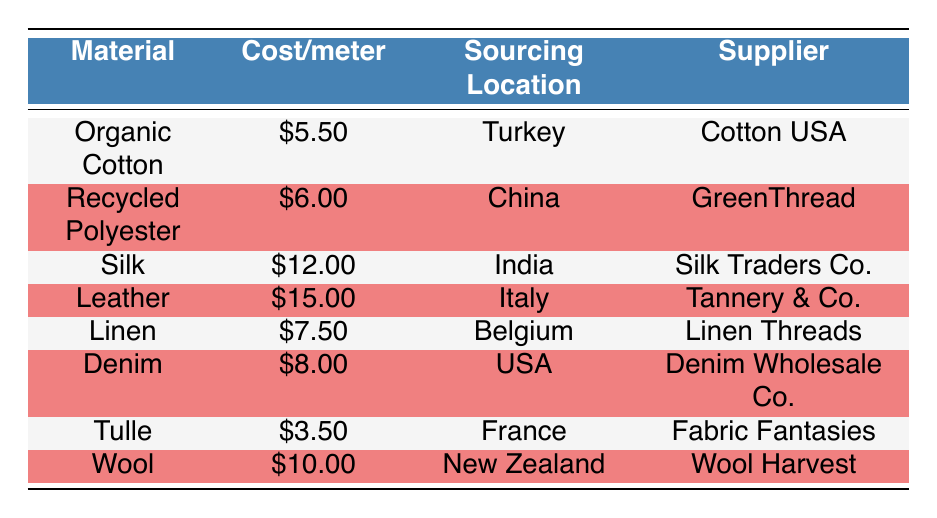What is the cost per meter of Organic Cotton? The table shows that the cost per meter of Organic Cotton is listed under the "Cost/meter" column next to the "Organic Cotton" row. This value is \$5.50.
Answer: \$5.50 Which material is sourced from Italy? Looking at the sourcing location column, we find that Leather is the material sourced from Italy.
Answer: Leather What is the average cost per meter of all materials listed? To find the average, we first sum the cost per meter of each material: \$5.50 + \$6.00 + \$12.00 + \$15.00 + \$7.50 + \$8.00 + \$3.50 + \$10.00 = \$67.50. There are 8 materials, so the average cost is \$67.50 / 8 = \$8.44.
Answer: \$8.44 Is Silk the most expensive material on the list? By comparing the cost per meter of Silk, which is \$12.00, with all other materials, we see that Leather at \$15.00 is more expensive than Silk. Therefore, Silk is not the most expensive material.
Answer: No What is the sourcing location of the material with the highest cost per meter? The material with the highest cost per meter is Leather, costing \$15.00. Referencing the sourcing location column for this row, we find it is sourced from Italy.
Answer: Italy Which two materials have a cost per meter below \$7? We look at the cost per meter column and find Tulle at \$3.50 and Organic Cotton at \$5.50. Both of these materials have costs below \$7.
Answer: Tulle and Organic Cotton Is there any material sourced from the USA? Checking the sourcing location column reveals that Denim is the only material listed with the USA as its sourcing location.
Answer: Yes What is the total cost per meter of Wool and Leather combined? First, we find the costs of Wool, which is \$10.00, and Leather, which is \$15.00. Adding these together gives us \$10.00 + \$15.00 = \$25.00.
Answer: \$25.00 